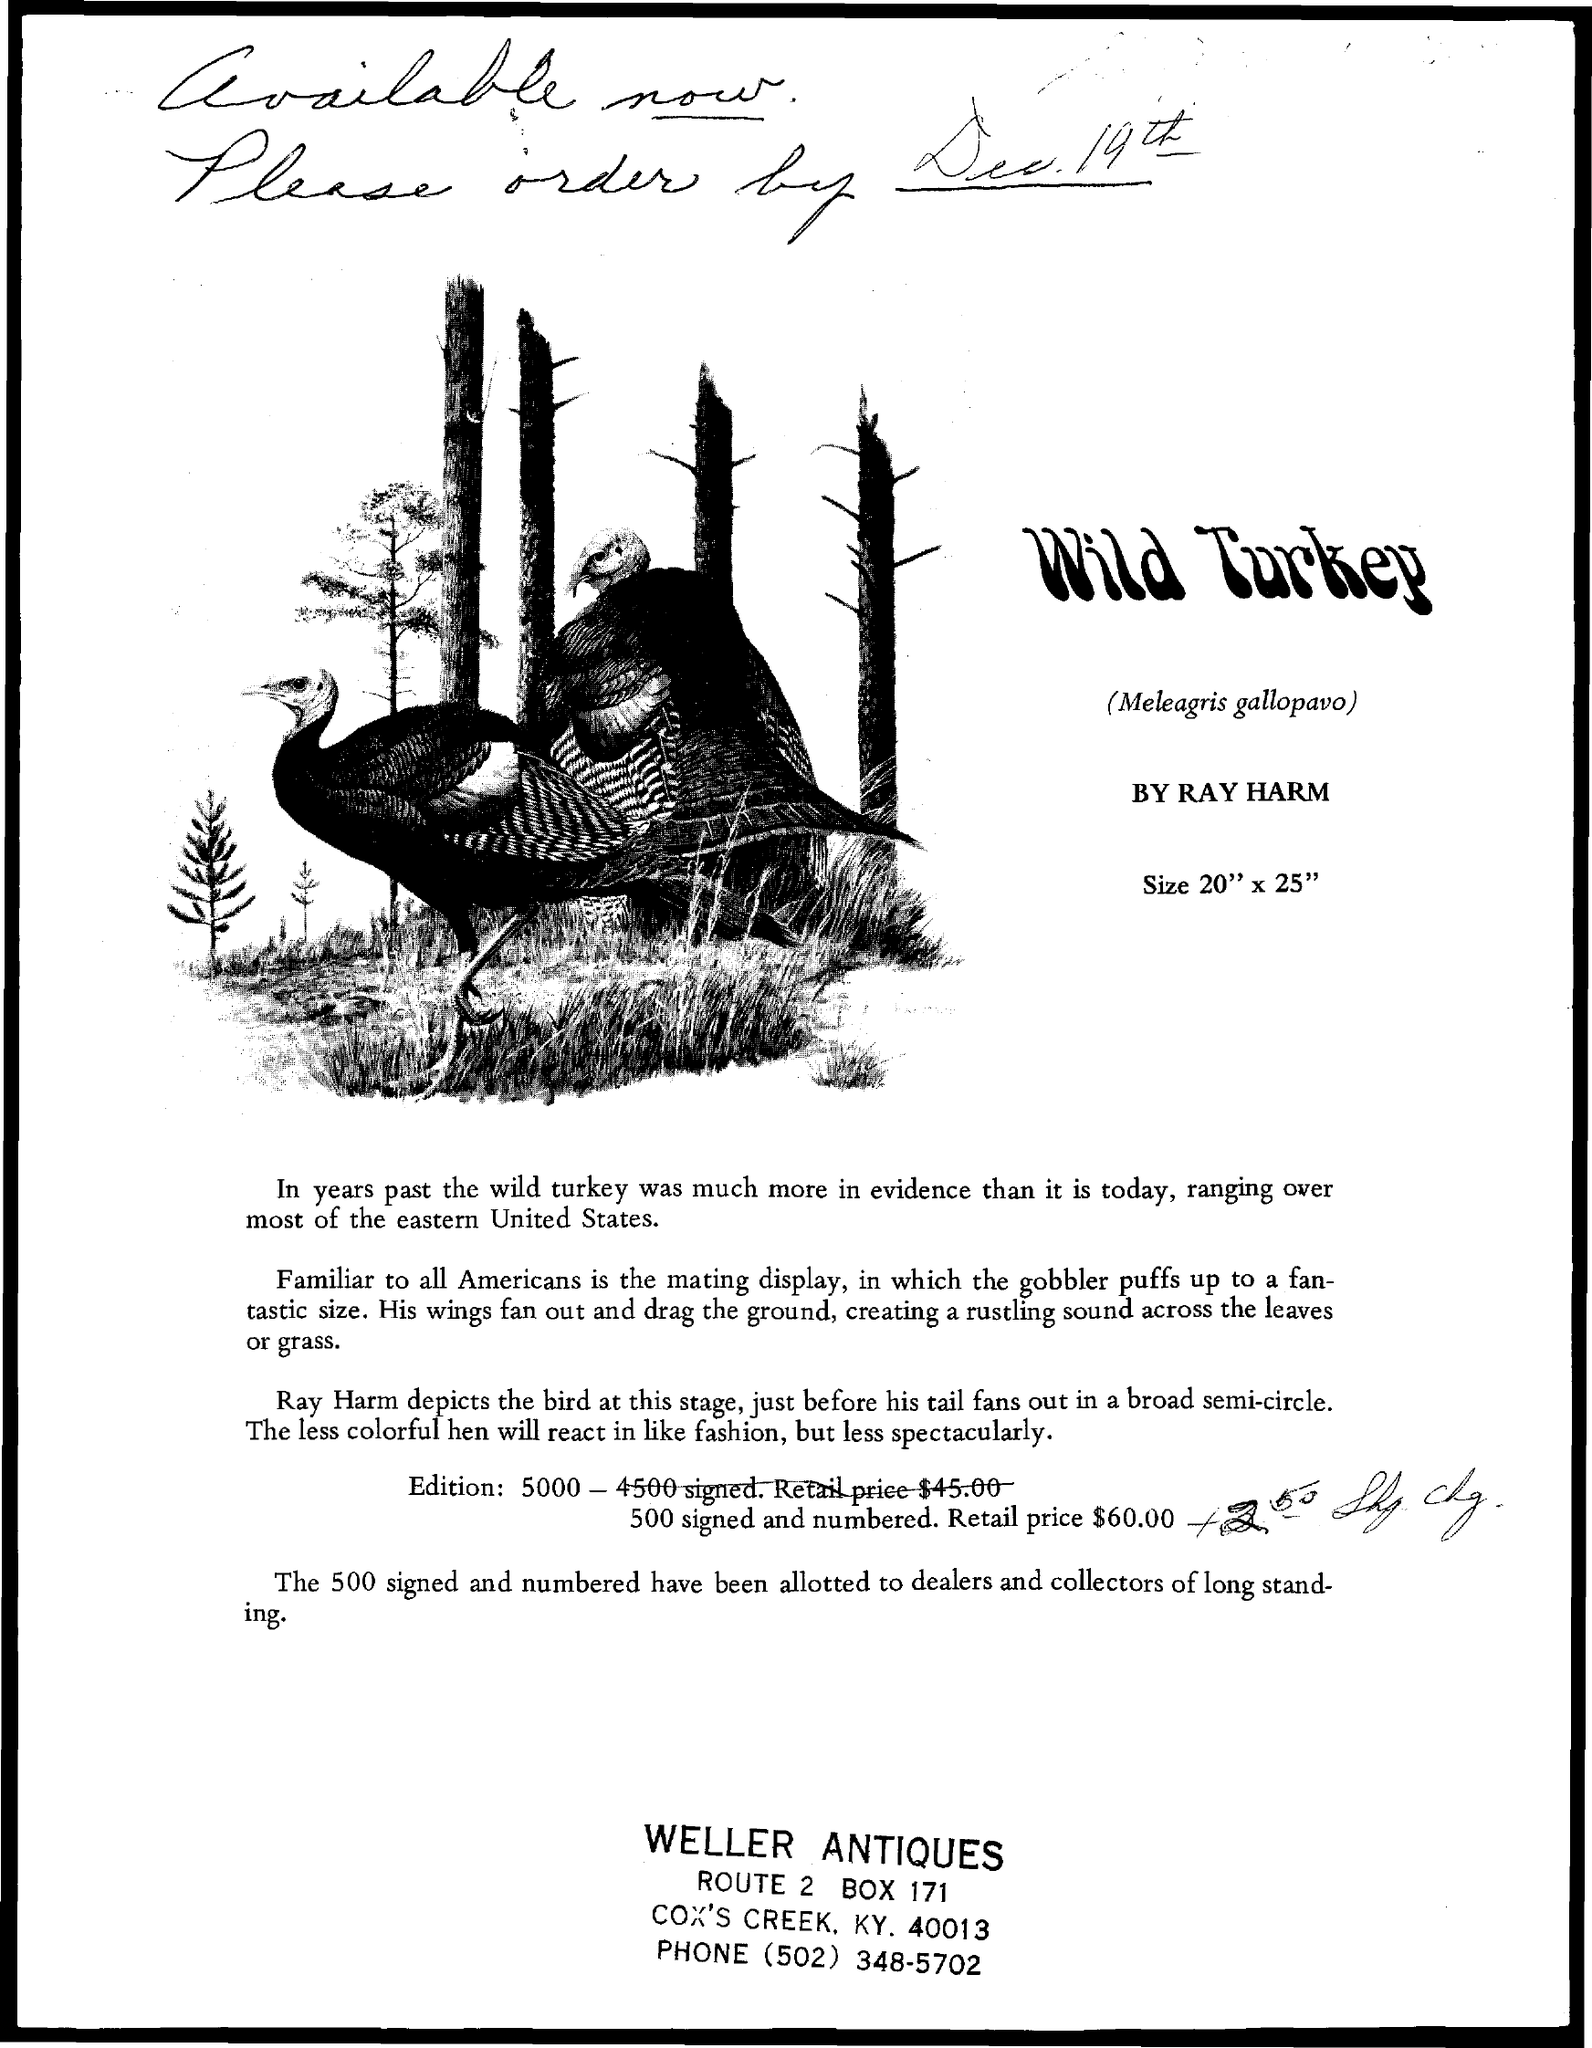Identify some key points in this picture. The BOX number is 171. The phone number is (502) 348-5702. 